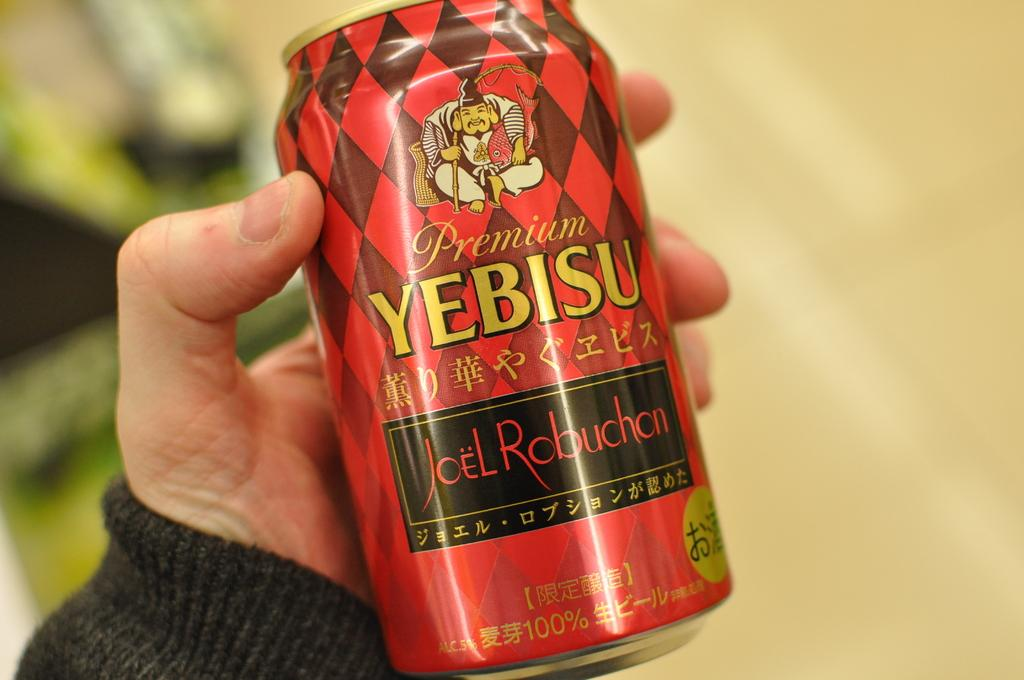<image>
Share a concise interpretation of the image provided. Someone is holding a can of Yebisu, which is red. 